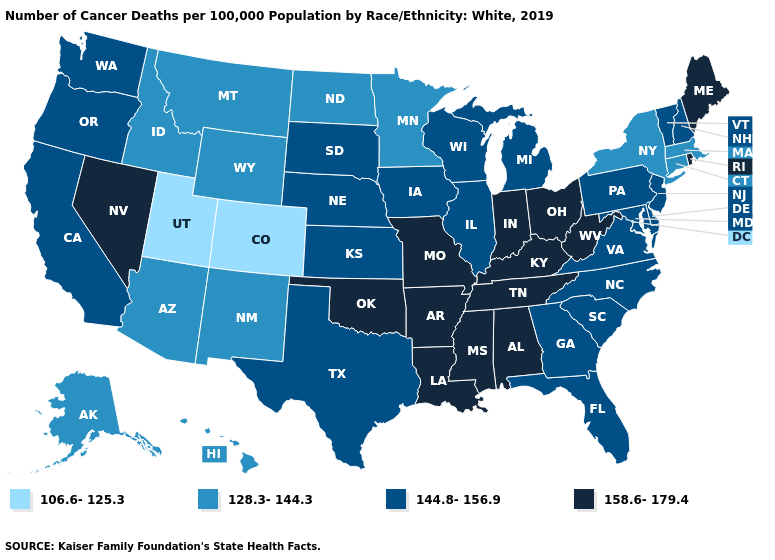Does New Mexico have a lower value than Massachusetts?
Concise answer only. No. What is the value of North Dakota?
Answer briefly. 128.3-144.3. What is the highest value in the USA?
Concise answer only. 158.6-179.4. Does the first symbol in the legend represent the smallest category?
Short answer required. Yes. What is the highest value in the USA?
Keep it brief. 158.6-179.4. Which states have the lowest value in the USA?
Keep it brief. Colorado, Utah. Does Utah have the lowest value in the USA?
Quick response, please. Yes. What is the lowest value in states that border Minnesota?
Short answer required. 128.3-144.3. Does Indiana have the highest value in the MidWest?
Concise answer only. Yes. Which states have the lowest value in the MidWest?
Short answer required. Minnesota, North Dakota. What is the value of Hawaii?
Write a very short answer. 128.3-144.3. Is the legend a continuous bar?
Quick response, please. No. Does Vermont have a higher value than Texas?
Concise answer only. No. Among the states that border Missouri , does Arkansas have the lowest value?
Give a very brief answer. No. 